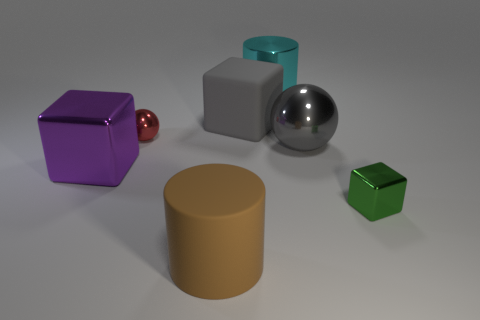What number of other things are there of the same shape as the green thing?
Keep it short and to the point. 2. What material is the green object that is the same size as the red metal sphere?
Ensure brevity in your answer.  Metal. There is a tiny object behind the metal block that is right of the block behind the gray metallic sphere; what color is it?
Offer a very short reply. Red. There is a big metal thing behind the matte block; does it have the same shape as the large thing in front of the purple cube?
Keep it short and to the point. Yes. What number of large matte cylinders are there?
Provide a short and direct response. 1. There is a cube that is the same size as the red object; what color is it?
Provide a short and direct response. Green. Is the material of the block on the right side of the big gray shiny ball the same as the big block on the left side of the red thing?
Make the answer very short. Yes. There is a shiny sphere that is in front of the small metallic object that is on the left side of the large cyan metal object; what size is it?
Make the answer very short. Large. What is the material of the sphere to the left of the big gray shiny ball?
Ensure brevity in your answer.  Metal. How many objects are either objects on the left side of the green block or large gray objects to the right of the cyan thing?
Offer a terse response. 6. 